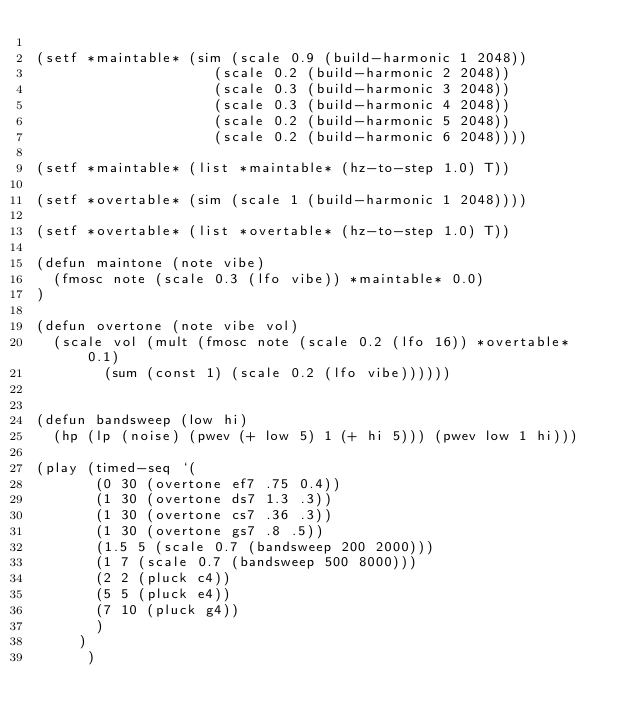Convert code to text. <code><loc_0><loc_0><loc_500><loc_500><_Lisp_>
(setf *maintable* (sim (scale 0.9 (build-harmonic 1 2048))
                     (scale 0.2 (build-harmonic 2 2048))
                     (scale 0.3 (build-harmonic 3 2048))
                     (scale 0.3 (build-harmonic 4 2048))
                     (scale 0.2 (build-harmonic 5 2048))
                     (scale 0.2 (build-harmonic 6 2048))))

(setf *maintable* (list *maintable* (hz-to-step 1.0) T))

(setf *overtable* (sim (scale 1 (build-harmonic 1 2048))))

(setf *overtable* (list *overtable* (hz-to-step 1.0) T))

(defun maintone (note vibe)
  (fmosc note (scale 0.3 (lfo vibe)) *maintable* 0.0)
)

(defun overtone (note vibe vol) 
  (scale vol (mult (fmosc note (scale 0.2 (lfo 16)) *overtable* 0.1) 
		    (sum (const 1) (scale 0.2 (lfo vibe))))))


(defun bandsweep (low hi)
  (hp (lp (noise) (pwev (+ low 5) 1 (+ hi 5))) (pwev low 1 hi)))

(play (timed-seq `(
		   (0 30 (overtone ef7 .75 0.4))
		   (1 30 (overtone ds7 1.3 .3))
		   (1 30 (overtone cs7 .36 .3))
		   (1 30 (overtone gs7 .8 .5))		   
		   (1.5 5 (scale 0.7 (bandsweep 200 2000)))
		   (1 7 (scale 0.7 (bandsweep 500 8000)))
		   (2 2 (pluck c4))
		   (5 5 (pluck e4))
		   (7 10 (pluck g4))
		   )
		 )
      )
       
</code> 